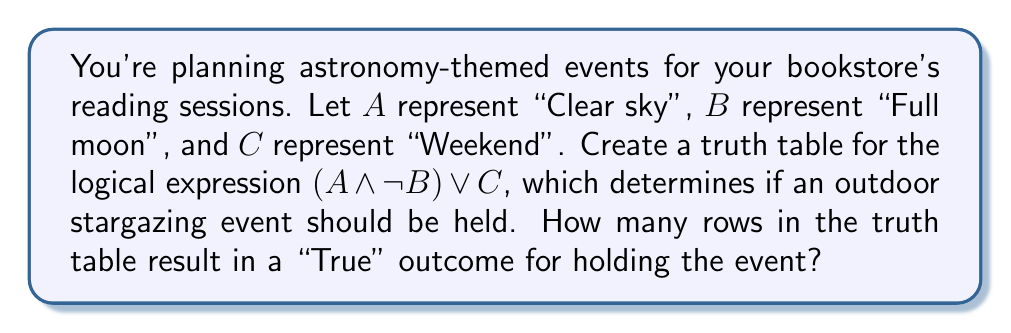Solve this math problem. Let's create the truth table step-by-step:

1) First, we list all possible combinations of A, B, and C:

   A | B | C
   ---------------
   0 | 0 | 0
   0 | 0 | 1
   0 | 1 | 0
   0 | 1 | 1
   1 | 0 | 0
   1 | 0 | 1
   1 | 1 | 0
   1 | 1 | 1

2) Now, let's evaluate $\neg B$:

   A | B | C | $\neg B$
   ----------------------
   0 | 0 | 0 |   1
   0 | 0 | 1 |   1
   0 | 1 | 0 |   0
   0 | 1 | 1 |   0
   1 | 0 | 0 |   1
   1 | 0 | 1 |   1
   1 | 1 | 0 |   0
   1 | 1 | 1 |   0

3) Next, we evaluate $A \land \neg B$:

   A | B | C | $\neg B$ | $A \land \neg B$
   ---------------------------------------
   0 | 0 | 0 |   1     |       0
   0 | 0 | 1 |   1     |       0
   0 | 1 | 0 |   0     |       0
   0 | 1 | 1 |   0     |       0
   1 | 0 | 0 |   1     |       1
   1 | 0 | 1 |   1     |       1
   1 | 1 | 0 |   0     |       0
   1 | 1 | 1 |   0     |       0

4) Finally, we evaluate $(A \land \neg B) \lor C$:

   A | B | C | $\neg B$ | $A \land \neg B$ | $(A \land \neg B) \lor C$
   ------------------------------------------------------------------
   0 | 0 | 0 |   1     |       0          |           0
   0 | 0 | 1 |   1     |       0          |           1
   0 | 1 | 0 |   0     |       0          |           0
   0 | 1 | 1 |   0     |       0          |           1
   1 | 0 | 0 |   1     |       1          |           1
   1 | 0 | 1 |   1     |       1          |           1
   1 | 1 | 0 |   0     |       0          |           0
   1 | 1 | 1 |   0     |       0          |           1

5) Counting the number of "True" (1) outcomes in the final column, we get 5.

Therefore, there are 5 rows in the truth table that result in a "True" outcome for holding the event.
Answer: 5 